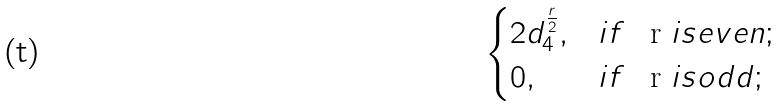Convert formula to latex. <formula><loc_0><loc_0><loc_500><loc_500>\begin{cases} 2 d _ { 4 } ^ { \frac { r } 2 } , & i f $ \, r $ i s e v e n ; \\ 0 , & i f $ \, r $ i s o d d ; \end{cases}</formula> 